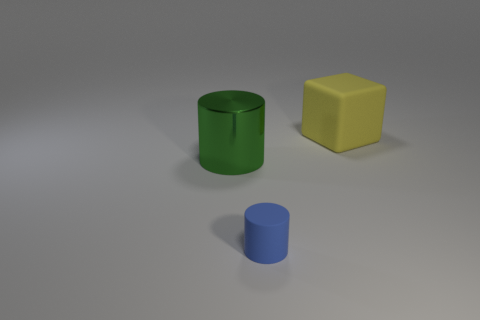Add 3 blue rubber spheres. How many objects exist? 6 Subtract all blocks. How many objects are left? 2 Subtract all large red matte cubes. Subtract all blue matte cylinders. How many objects are left? 2 Add 2 yellow objects. How many yellow objects are left? 3 Add 2 metallic objects. How many metallic objects exist? 3 Subtract 0 purple cubes. How many objects are left? 3 